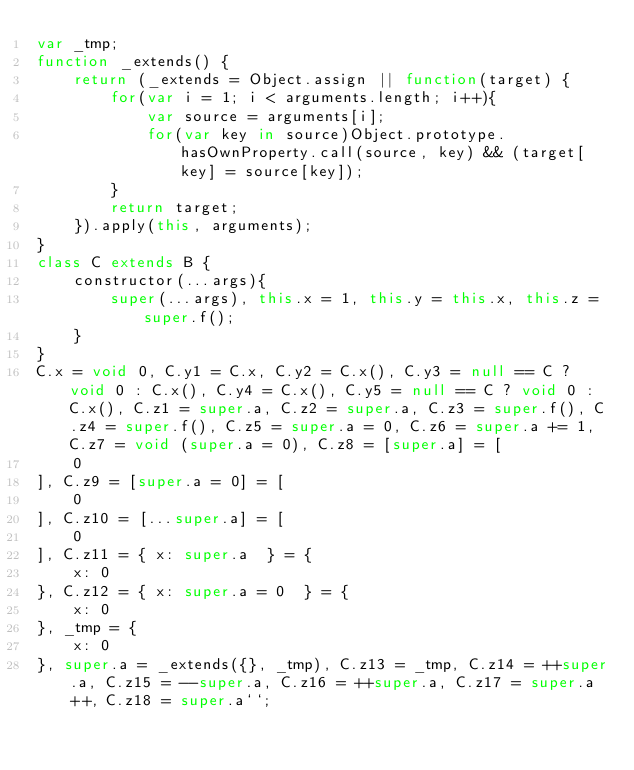Convert code to text. <code><loc_0><loc_0><loc_500><loc_500><_JavaScript_>var _tmp;
function _extends() {
    return (_extends = Object.assign || function(target) {
        for(var i = 1; i < arguments.length; i++){
            var source = arguments[i];
            for(var key in source)Object.prototype.hasOwnProperty.call(source, key) && (target[key] = source[key]);
        }
        return target;
    }).apply(this, arguments);
}
class C extends B {
    constructor(...args){
        super(...args), this.x = 1, this.y = this.x, this.z = super.f();
    }
}
C.x = void 0, C.y1 = C.x, C.y2 = C.x(), C.y3 = null == C ? void 0 : C.x(), C.y4 = C.x(), C.y5 = null == C ? void 0 : C.x(), C.z1 = super.a, C.z2 = super.a, C.z3 = super.f(), C.z4 = super.f(), C.z5 = super.a = 0, C.z6 = super.a += 1, C.z7 = void (super.a = 0), C.z8 = [super.a] = [
    0
], C.z9 = [super.a = 0] = [
    0
], C.z10 = [...super.a] = [
    0
], C.z11 = { x: super.a  } = {
    x: 0
}, C.z12 = { x: super.a = 0  } = {
    x: 0
}, _tmp = {
    x: 0
}, super.a = _extends({}, _tmp), C.z13 = _tmp, C.z14 = ++super.a, C.z15 = --super.a, C.z16 = ++super.a, C.z17 = super.a++, C.z18 = super.a``;
</code> 